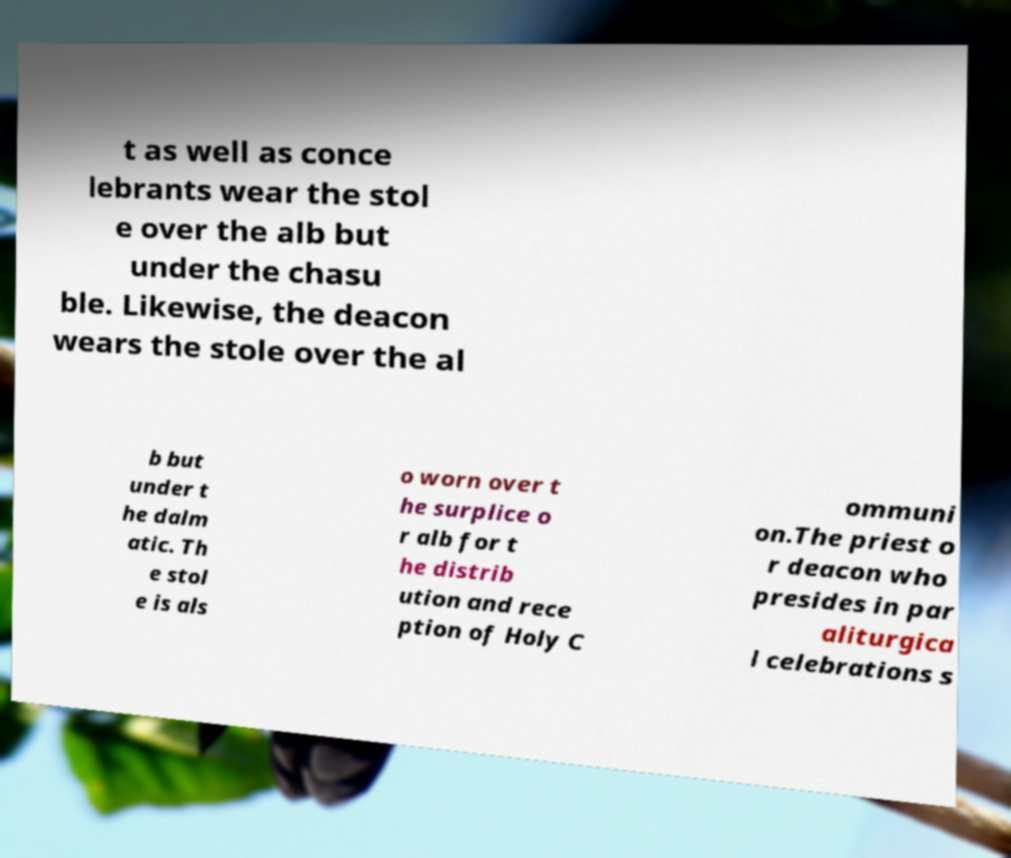I need the written content from this picture converted into text. Can you do that? t as well as conce lebrants wear the stol e over the alb but under the chasu ble. Likewise, the deacon wears the stole over the al b but under t he dalm atic. Th e stol e is als o worn over t he surplice o r alb for t he distrib ution and rece ption of Holy C ommuni on.The priest o r deacon who presides in par aliturgica l celebrations s 